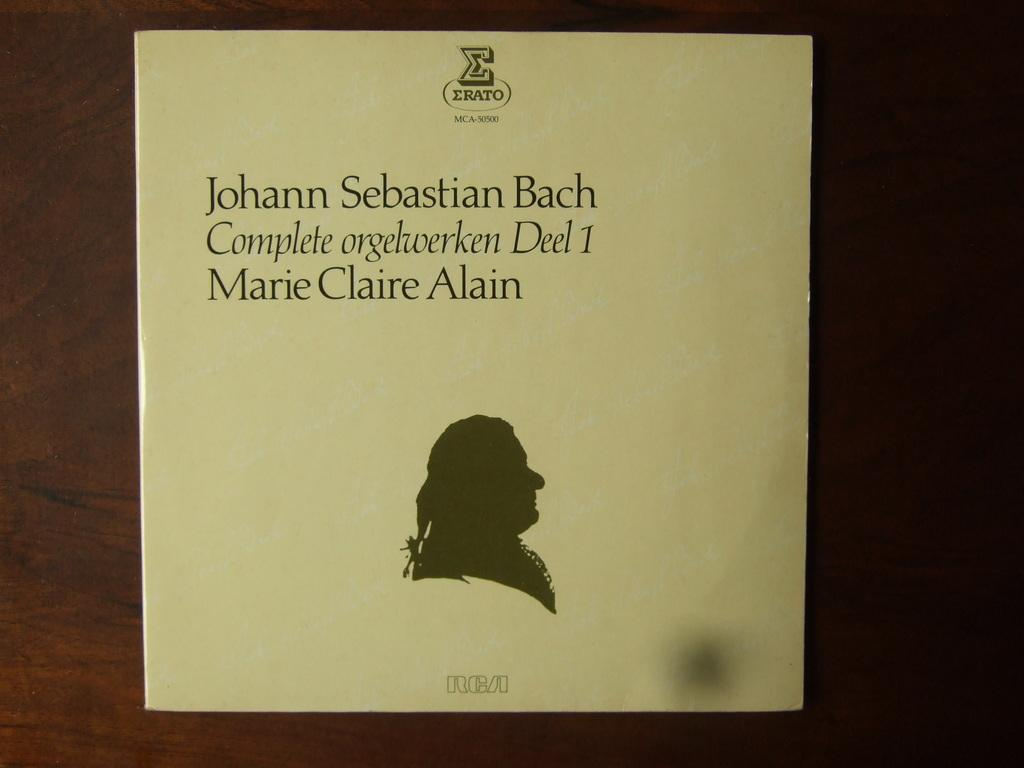What is present on the paper in the image? Something is written on the paper. What can be inferred about the purpose of the paper based on the presence of writing? The paper may be used for note-taking, writing a message, or recording information. On what type of surface is the paper placed? The paper is on a brown surface. What type of coil is wrapped around the paper in the image? There is no coil present in the image; it only features a paper with writing on it and a brown surface. 